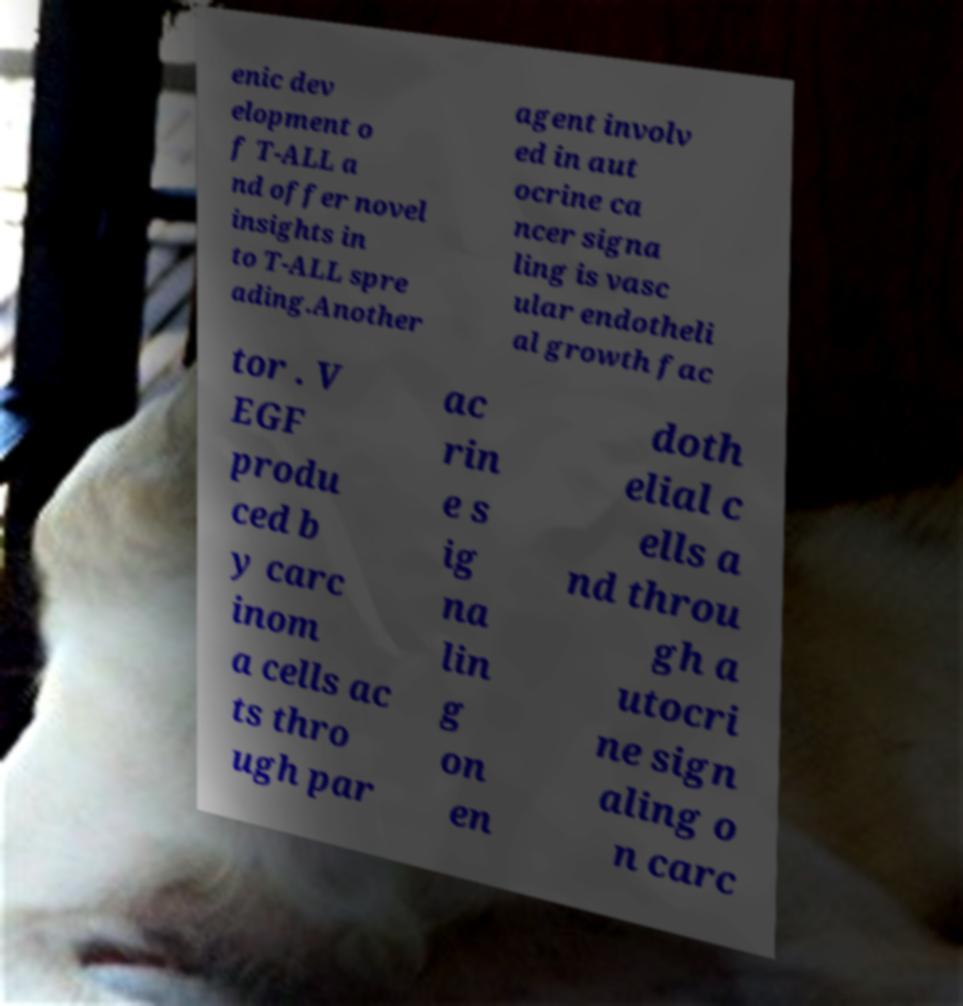Can you accurately transcribe the text from the provided image for me? enic dev elopment o f T-ALL a nd offer novel insights in to T-ALL spre ading.Another agent involv ed in aut ocrine ca ncer signa ling is vasc ular endotheli al growth fac tor . V EGF produ ced b y carc inom a cells ac ts thro ugh par ac rin e s ig na lin g on en doth elial c ells a nd throu gh a utocri ne sign aling o n carc 